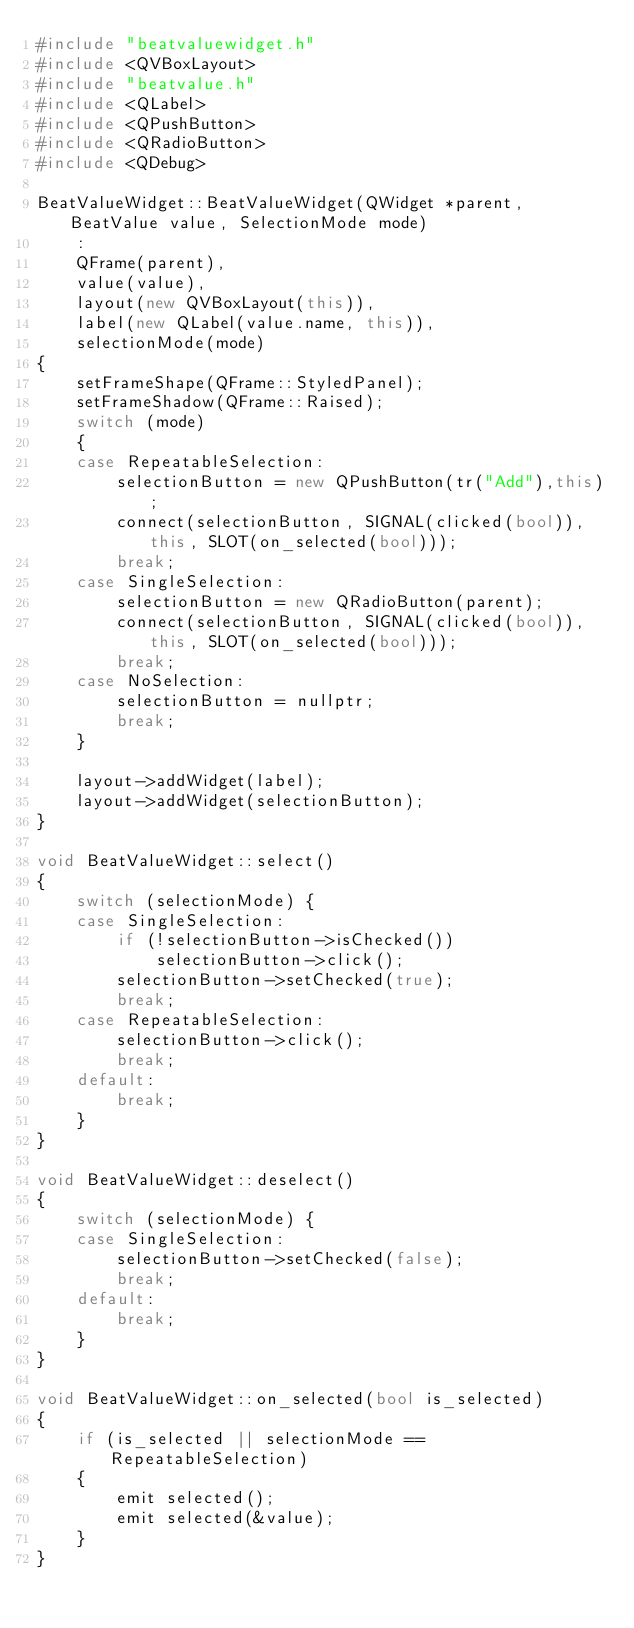<code> <loc_0><loc_0><loc_500><loc_500><_C++_>#include "beatvaluewidget.h"
#include <QVBoxLayout>
#include "beatvalue.h"
#include <QLabel>
#include <QPushButton>
#include <QRadioButton>
#include <QDebug>

BeatValueWidget::BeatValueWidget(QWidget *parent, BeatValue value, SelectionMode mode)
    :
    QFrame(parent),
    value(value),
    layout(new QVBoxLayout(this)),
    label(new QLabel(value.name, this)),
    selectionMode(mode)
{
    setFrameShape(QFrame::StyledPanel);
    setFrameShadow(QFrame::Raised);
    switch (mode)
    {
    case RepeatableSelection:
        selectionButton = new QPushButton(tr("Add"),this);
        connect(selectionButton, SIGNAL(clicked(bool)), this, SLOT(on_selected(bool)));
        break;
    case SingleSelection:
        selectionButton = new QRadioButton(parent);
        connect(selectionButton, SIGNAL(clicked(bool)), this, SLOT(on_selected(bool)));
        break;
    case NoSelection:
        selectionButton = nullptr;
        break;
    }

    layout->addWidget(label);
    layout->addWidget(selectionButton);
}

void BeatValueWidget::select()
{
    switch (selectionMode) {
    case SingleSelection:
        if (!selectionButton->isChecked())
            selectionButton->click();
        selectionButton->setChecked(true);
        break;
    case RepeatableSelection:
        selectionButton->click();
        break;
    default:
        break;
    }
}

void BeatValueWidget::deselect()
{
    switch (selectionMode) {
    case SingleSelection:
        selectionButton->setChecked(false);
        break;
    default:
        break;
    }
}

void BeatValueWidget::on_selected(bool is_selected)
{
    if (is_selected || selectionMode == RepeatableSelection)
    {
        emit selected();
        emit selected(&value);
    }
}
</code> 